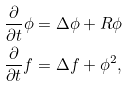<formula> <loc_0><loc_0><loc_500><loc_500>\frac { \partial } { \partial t } \phi & = \Delta \phi + R \phi \\ \frac { \partial } { \partial t } f & = \Delta f + \phi ^ { 2 } ,</formula> 